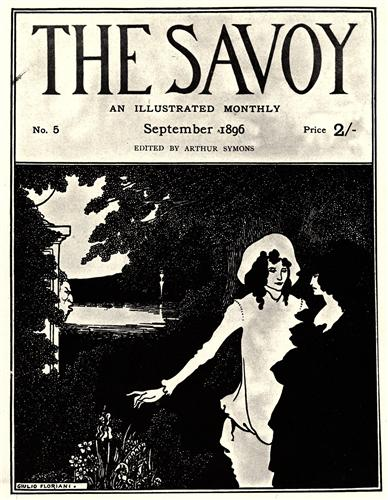What do you see happening in this image? The image portrays a captivating cover of 'The Savoy,' a notable illustrated monthly magazine from the late 19th century. This specific cover, issue number 5 from September 1896, is adorned with elegant Art Nouveau design elements. The scene illustrates a serene garden setting where a river quietly flows in the background. At the heart of the image is a couple, presumably engaged in a romantic or contemplative moment. The woman, in a flowing white dress, symbolizes purity and tranquility, adding a timeless charm to the composition. The monochromatic palette emphasizes the period's artistic sensibilities, and the mention of the magazine price, 2 shillings, serves as a delightful historical touch, enhancing the overall nostalgic feel of the artwork. 